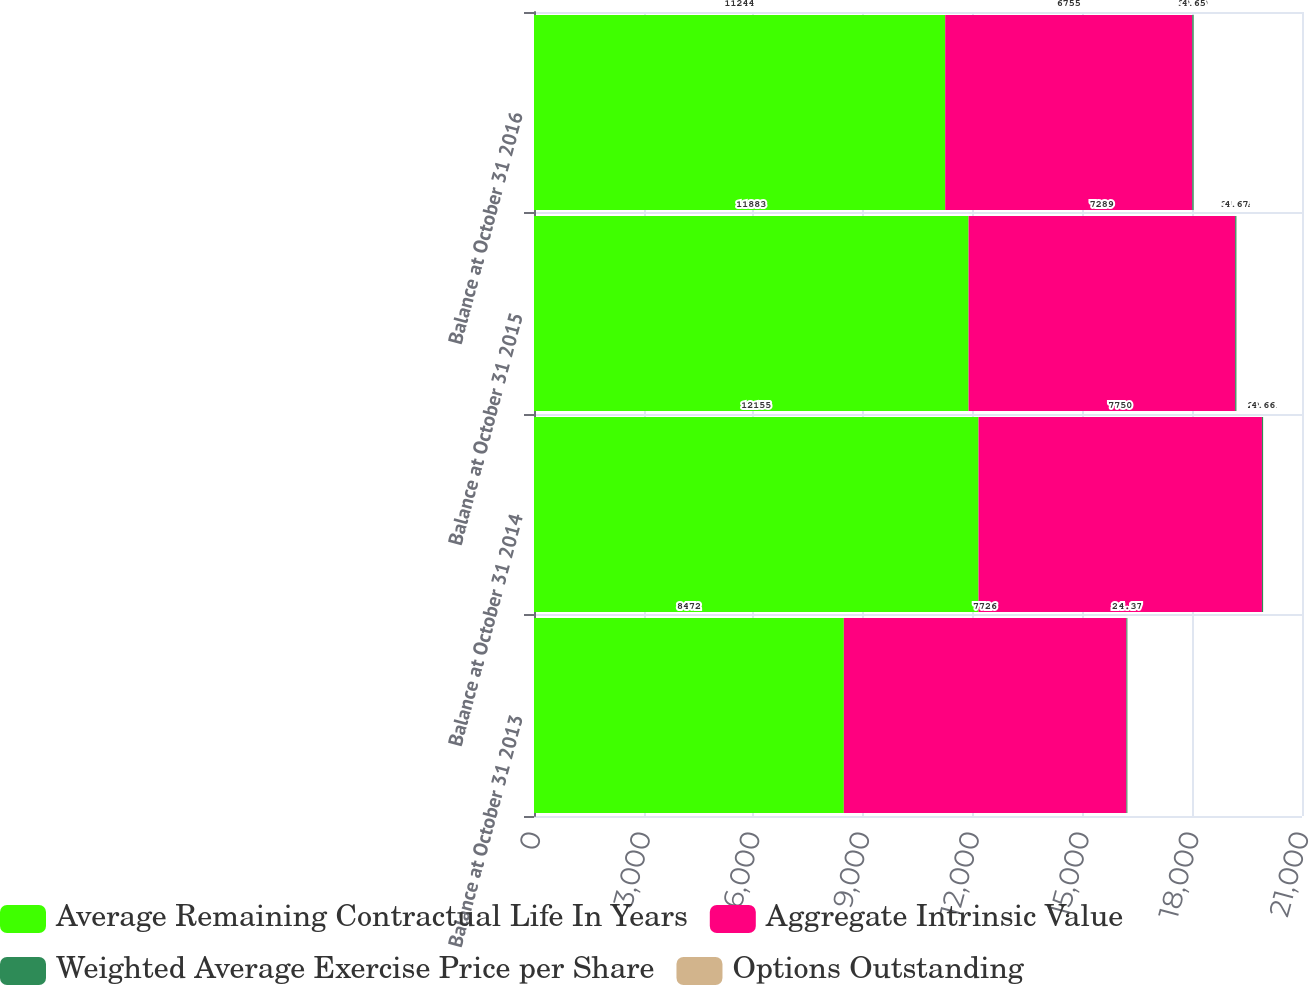Convert chart. <chart><loc_0><loc_0><loc_500><loc_500><stacked_bar_chart><ecel><fcel>Balance at October 31 2013<fcel>Balance at October 31 2014<fcel>Balance at October 31 2015<fcel>Balance at October 31 2016<nl><fcel>Average Remaining Contractual Life In Years<fcel>8472<fcel>12155<fcel>11883<fcel>11244<nl><fcel>Aggregate Intrinsic Value<fcel>7726<fcel>7750<fcel>7289<fcel>6755<nl><fcel>Weighted Average Exercise Price per Share<fcel>26.87<fcel>29.81<fcel>34.94<fcel>39.59<nl><fcel>Options Outstanding<fcel>4.3<fcel>4.66<fcel>4.67<fcel>4.65<nl></chart> 